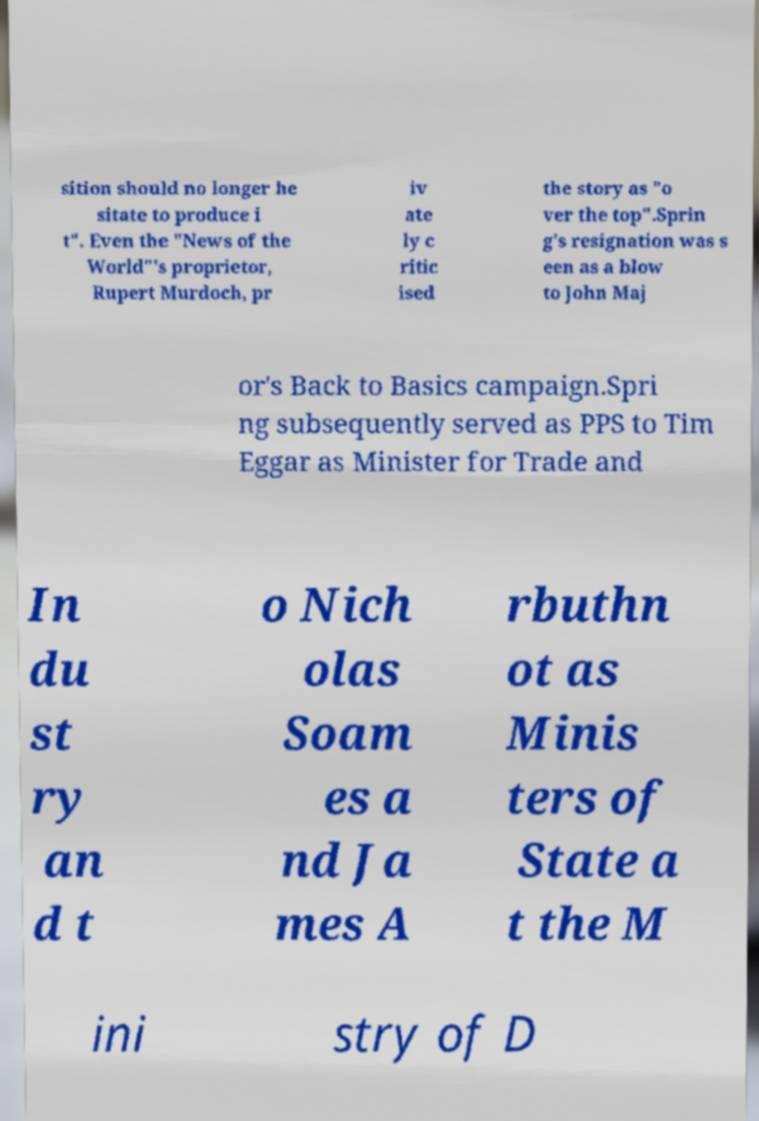Can you accurately transcribe the text from the provided image for me? sition should no longer he sitate to produce i t". Even the "News of the World"'s proprietor, Rupert Murdoch, pr iv ate ly c ritic ised the story as "o ver the top".Sprin g's resignation was s een as a blow to John Maj or's Back to Basics campaign.Spri ng subsequently served as PPS to Tim Eggar as Minister for Trade and In du st ry an d t o Nich olas Soam es a nd Ja mes A rbuthn ot as Minis ters of State a t the M ini stry of D 